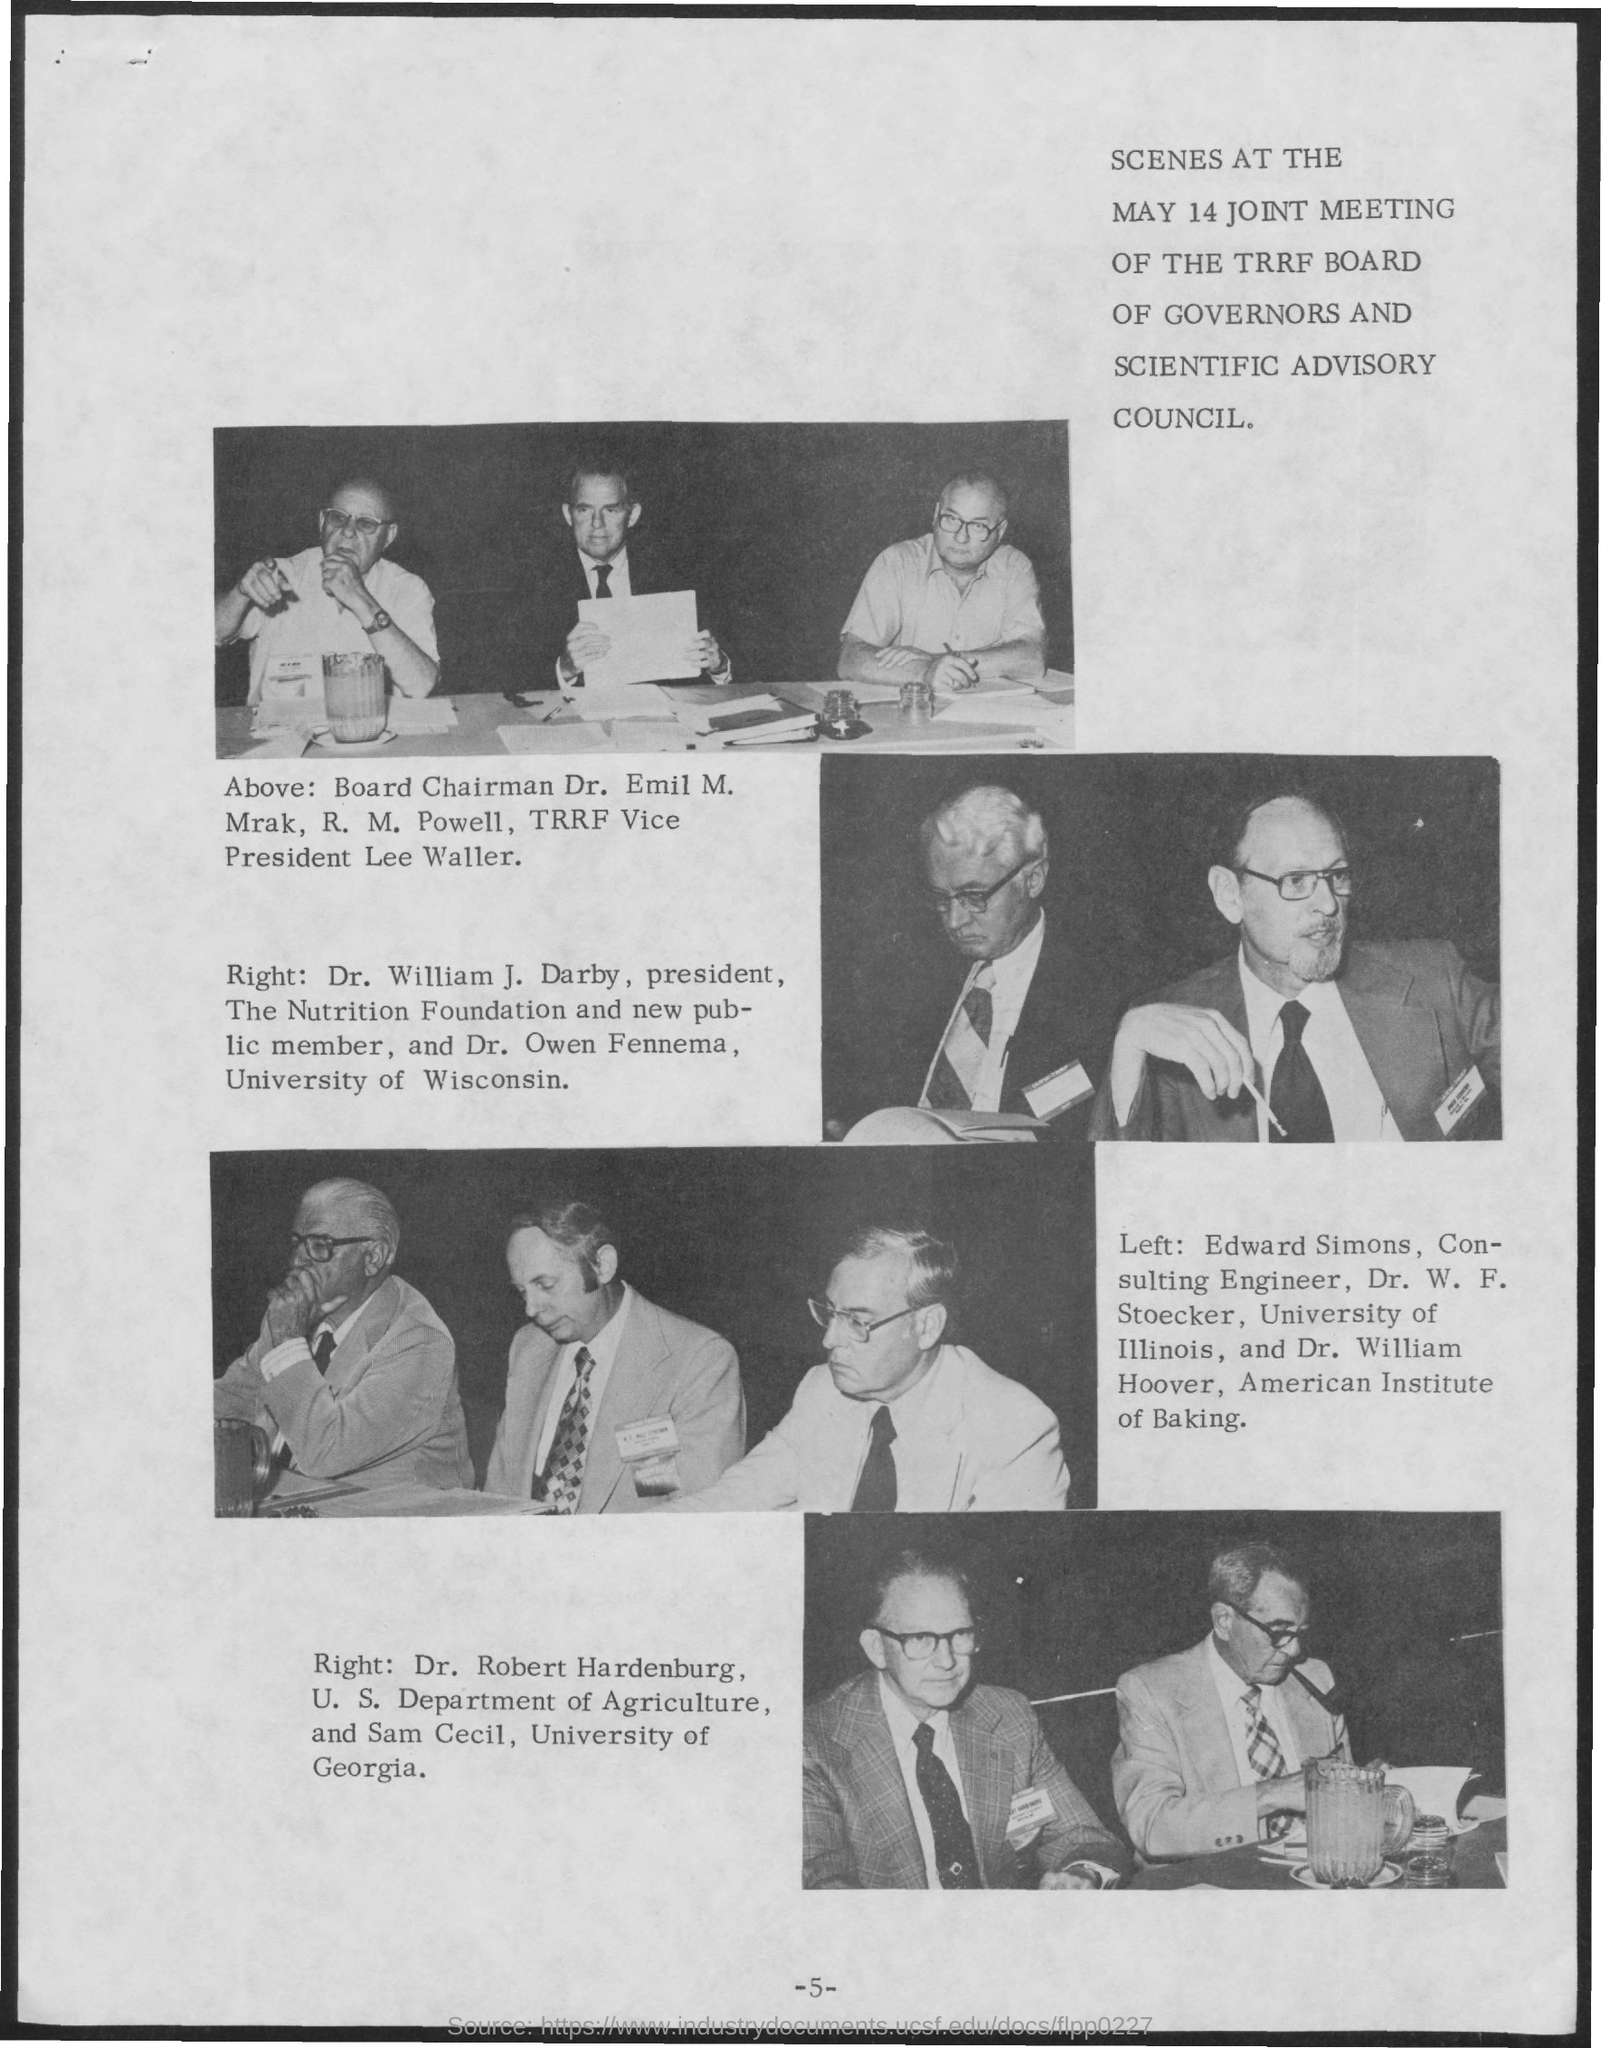Identify some key points in this picture. The Board Chairman is Dr. Emil M. Mrak. On May 14, the Joint Meeting of the TRRF Board of Governors and Scientific Advisory Council was held, during which all participants actively contributed to the discussion. The joint meeting took place on May 14. Edward Simons is a consulting engineer. 